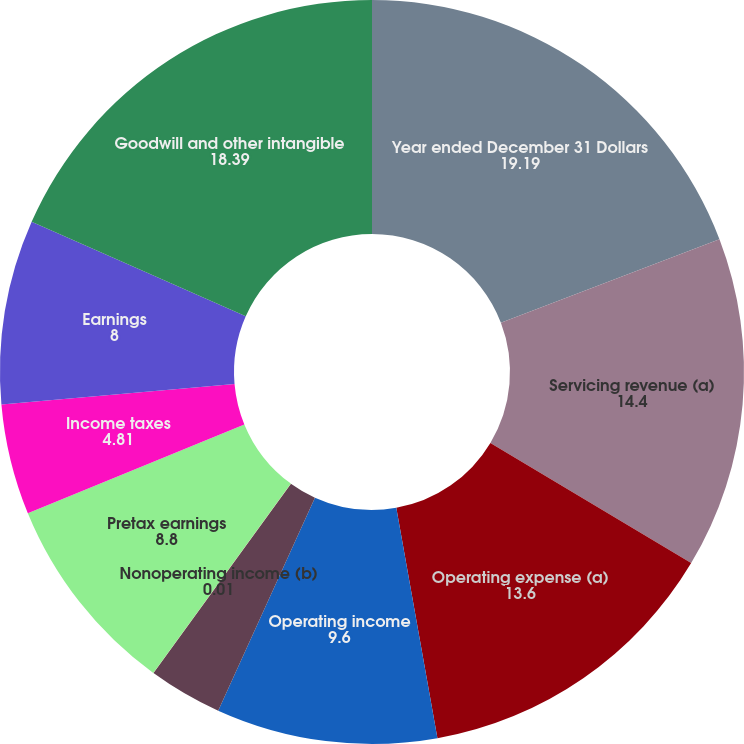Convert chart to OTSL. <chart><loc_0><loc_0><loc_500><loc_500><pie_chart><fcel>Year ended December 31 Dollars<fcel>Servicing revenue (a)<fcel>Operating expense (a)<fcel>Operating income<fcel>Debt financing<fcel>Nonoperating income (b)<fcel>Pretax earnings<fcel>Income taxes<fcel>Earnings<fcel>Goodwill and other intangible<nl><fcel>19.19%<fcel>14.4%<fcel>13.6%<fcel>9.6%<fcel>3.21%<fcel>0.01%<fcel>8.8%<fcel>4.81%<fcel>8.0%<fcel>18.39%<nl></chart> 